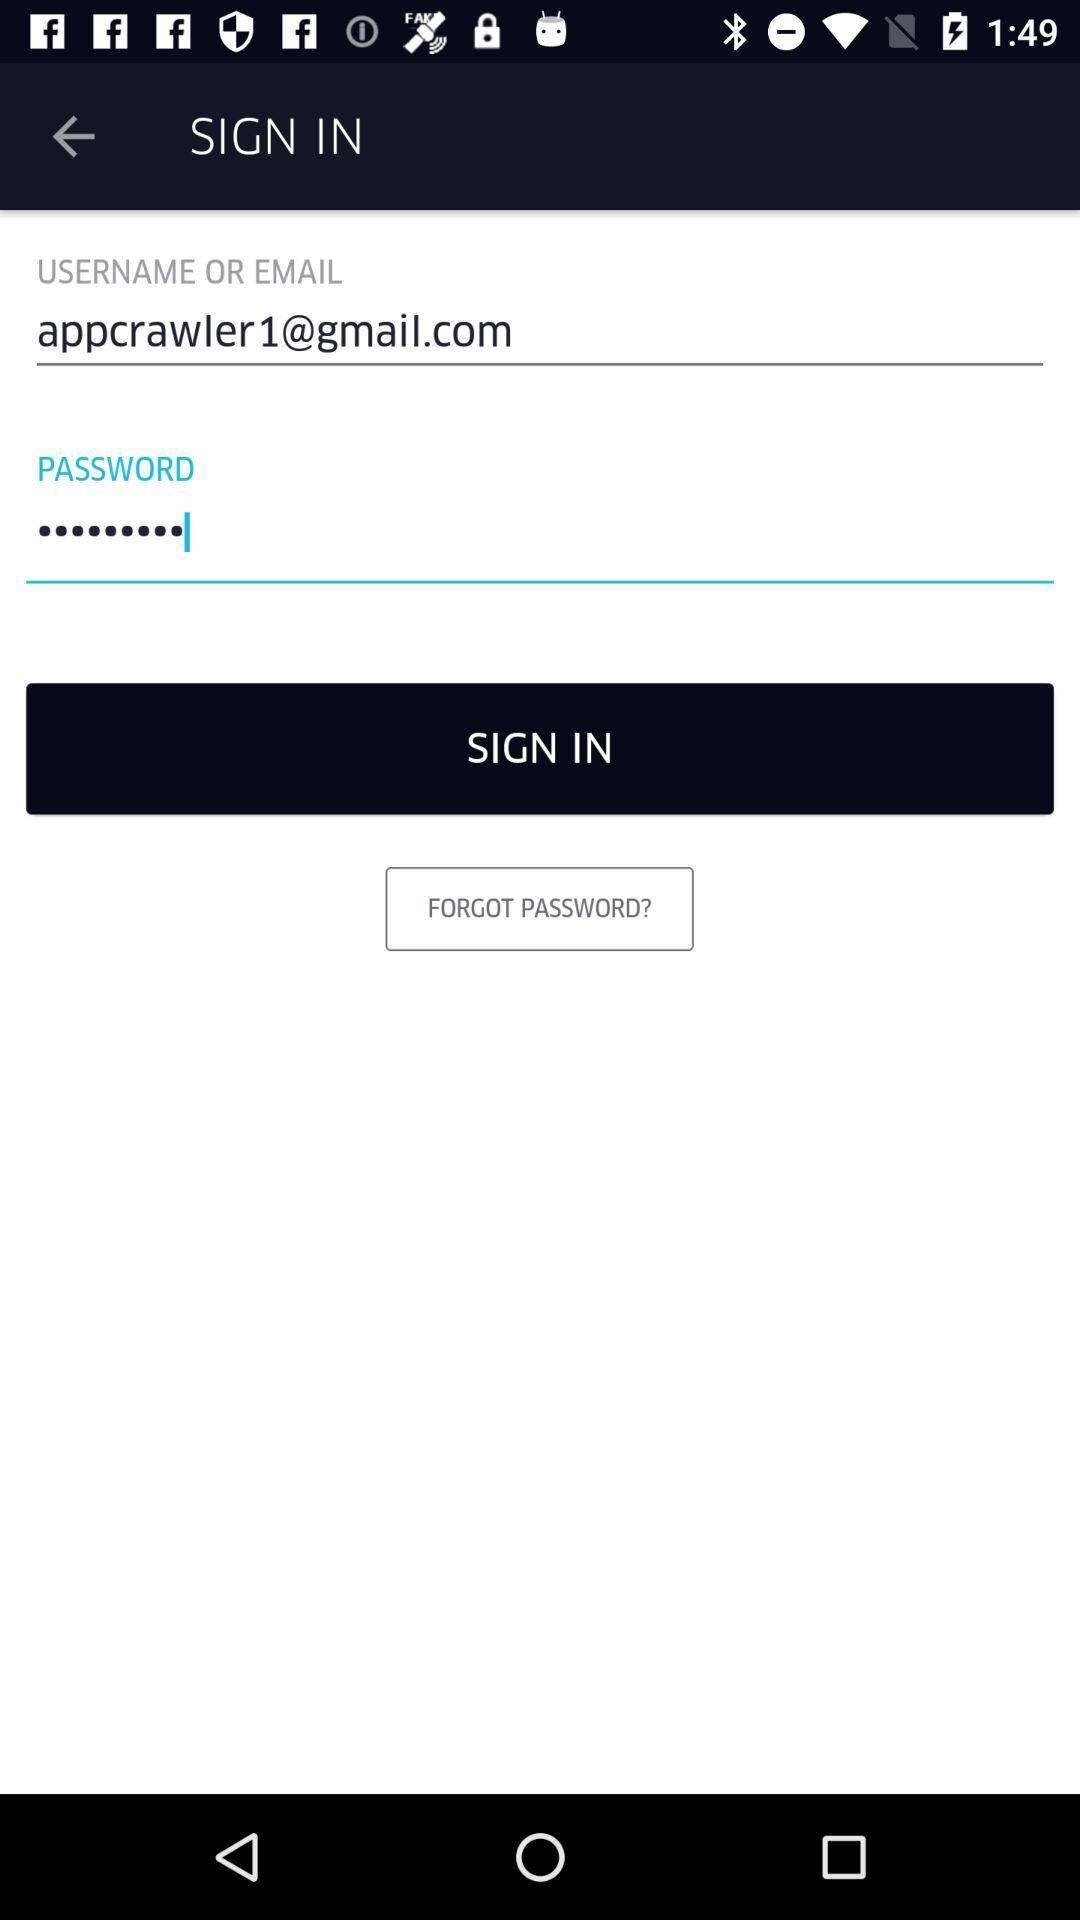How many characters are required for the password?
When the provided information is insufficient, respond with <no answer>. <no answer> 